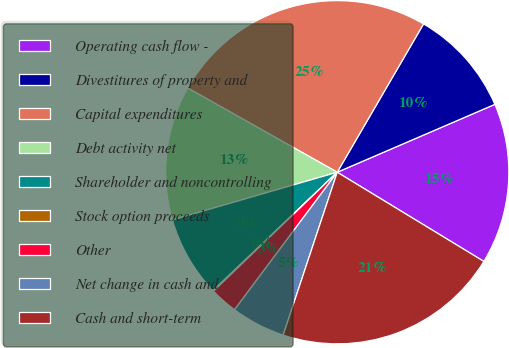Convert chart. <chart><loc_0><loc_0><loc_500><loc_500><pie_chart><fcel>Operating cash flow -<fcel>Divestitures of property and<fcel>Capital expenditures<fcel>Debt activity net<fcel>Shareholder and noncontrolling<fcel>Stock option proceeds<fcel>Other<fcel>Net change in cash and<fcel>Cash and short-term<nl><fcel>15.17%<fcel>10.14%<fcel>25.22%<fcel>12.65%<fcel>7.62%<fcel>0.08%<fcel>2.6%<fcel>5.11%<fcel>21.4%<nl></chart> 